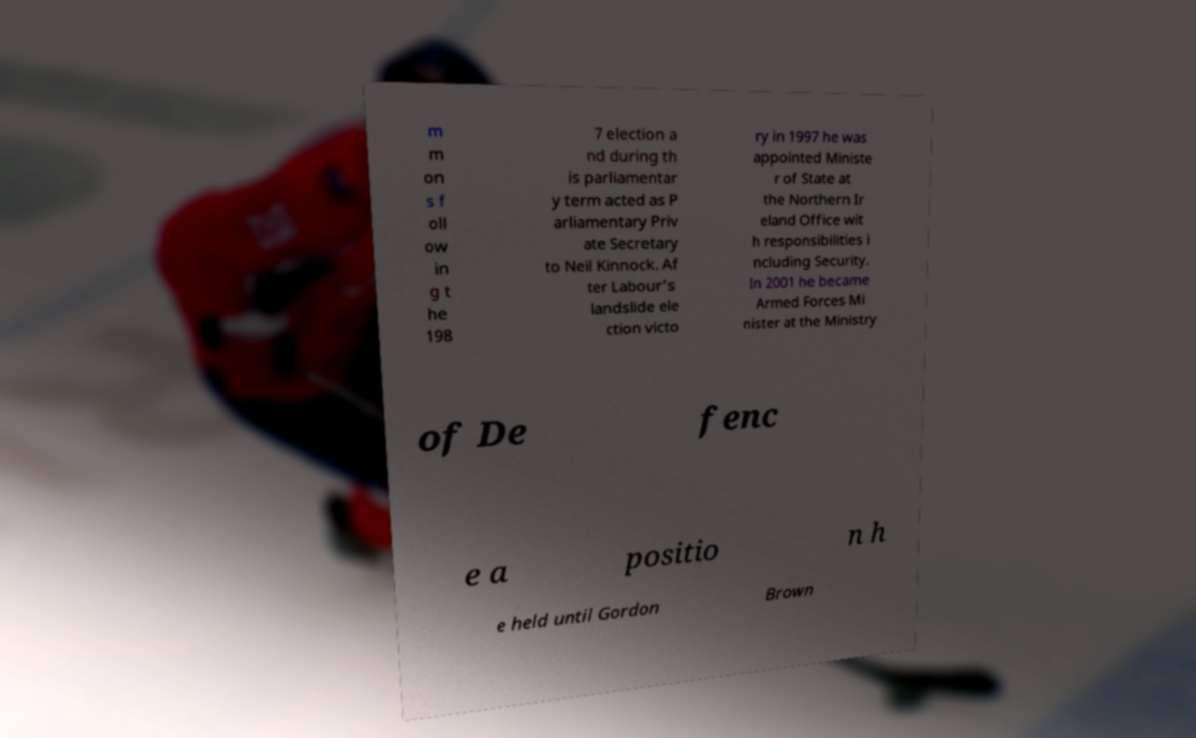What messages or text are displayed in this image? I need them in a readable, typed format. m m on s f oll ow in g t he 198 7 election a nd during th is parliamentar y term acted as P arliamentary Priv ate Secretary to Neil Kinnock. Af ter Labour's landslide ele ction victo ry in 1997 he was appointed Ministe r of State at the Northern Ir eland Office wit h responsibilities i ncluding Security. In 2001 he became Armed Forces Mi nister at the Ministry of De fenc e a positio n h e held until Gordon Brown 